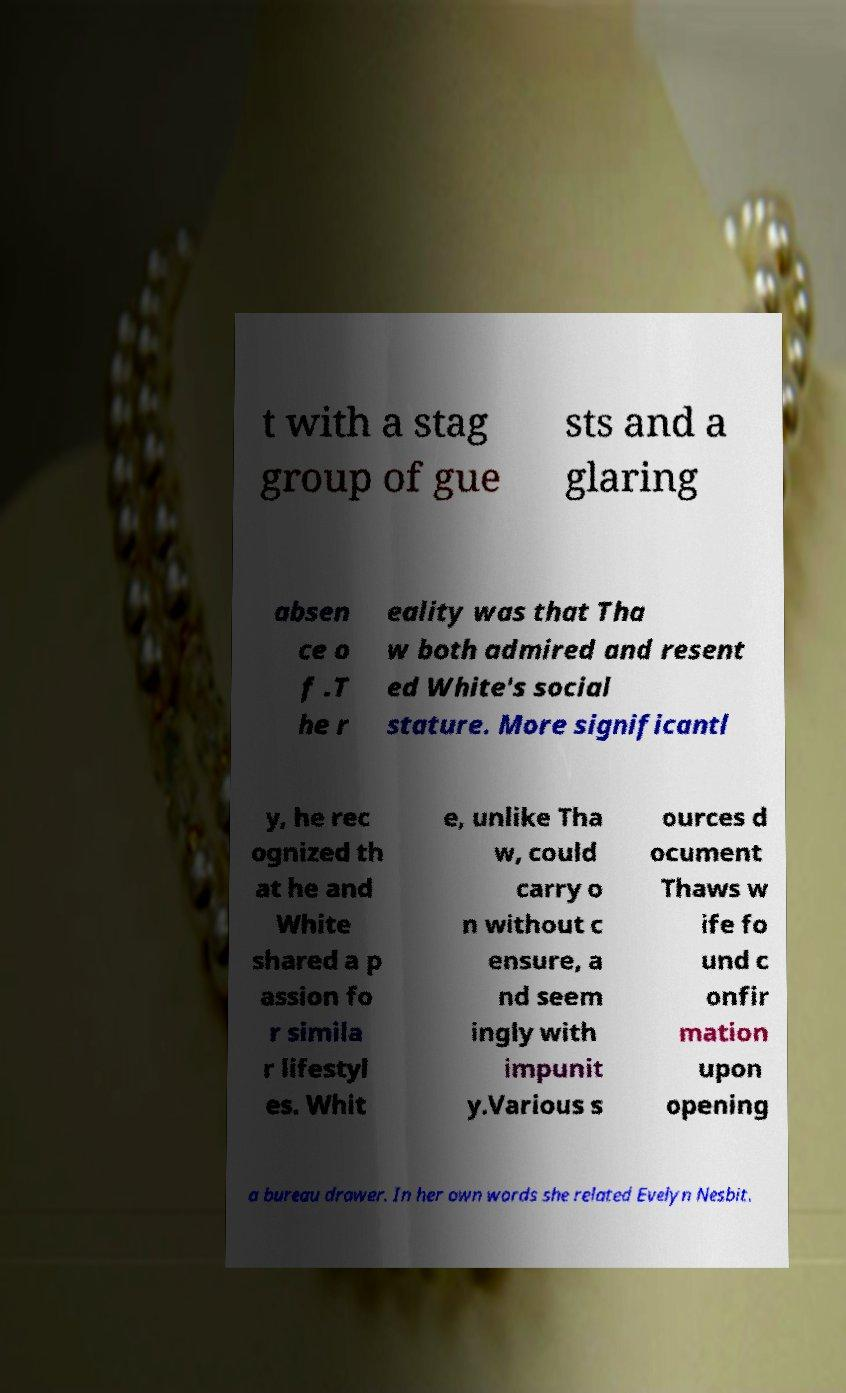What messages or text are displayed in this image? I need them in a readable, typed format. t with a stag group of gue sts and a glaring absen ce o f .T he r eality was that Tha w both admired and resent ed White's social stature. More significantl y, he rec ognized th at he and White shared a p assion fo r simila r lifestyl es. Whit e, unlike Tha w, could carry o n without c ensure, a nd seem ingly with impunit y.Various s ources d ocument Thaws w ife fo und c onfir mation upon opening a bureau drawer. In her own words she related Evelyn Nesbit. 